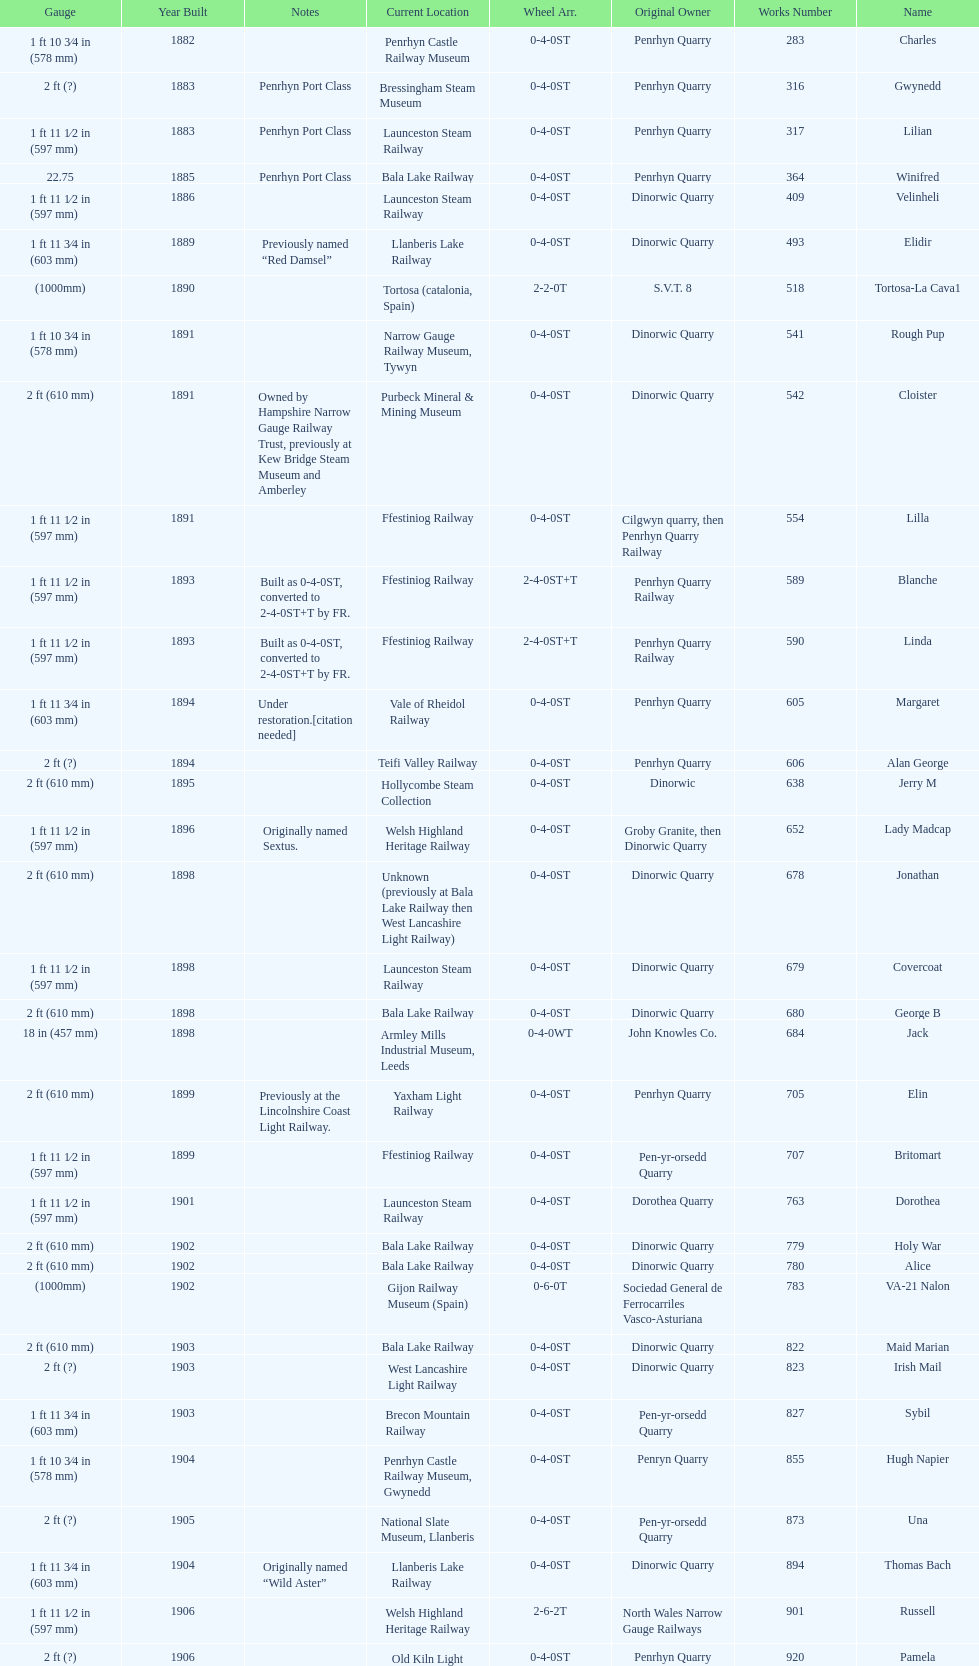How many steam locomotives are currently located at the bala lake railway? 364. Can you give me this table as a dict? {'header': ['Gauge', 'Year Built', 'Notes', 'Current Location', 'Wheel Arr.', 'Original Owner', 'Works Number', 'Name'], 'rows': [['1\xa0ft 10\xa03⁄4\xa0in (578\xa0mm)', '1882', '', 'Penrhyn Castle Railway Museum', '0-4-0ST', 'Penrhyn Quarry', '283', 'Charles'], ['2\xa0ft (?)', '1883', 'Penrhyn Port Class', 'Bressingham Steam Museum', '0-4-0ST', 'Penrhyn Quarry', '316', 'Gwynedd'], ['1\xa0ft 11\xa01⁄2\xa0in (597\xa0mm)', '1883', 'Penrhyn Port Class', 'Launceston Steam Railway', '0-4-0ST', 'Penrhyn Quarry', '317', 'Lilian'], ['22.75', '1885', 'Penrhyn Port Class', 'Bala Lake Railway', '0-4-0ST', 'Penrhyn Quarry', '364', 'Winifred'], ['1\xa0ft 11\xa01⁄2\xa0in (597\xa0mm)', '1886', '', 'Launceston Steam Railway', '0-4-0ST', 'Dinorwic Quarry', '409', 'Velinheli'], ['1\xa0ft 11\xa03⁄4\xa0in (603\xa0mm)', '1889', 'Previously named “Red Damsel”', 'Llanberis Lake Railway', '0-4-0ST', 'Dinorwic Quarry', '493', 'Elidir'], ['(1000mm)', '1890', '', 'Tortosa (catalonia, Spain)', '2-2-0T', 'S.V.T. 8', '518', 'Tortosa-La Cava1'], ['1\xa0ft 10\xa03⁄4\xa0in (578\xa0mm)', '1891', '', 'Narrow Gauge Railway Museum, Tywyn', '0-4-0ST', 'Dinorwic Quarry', '541', 'Rough Pup'], ['2\xa0ft (610\xa0mm)', '1891', 'Owned by Hampshire Narrow Gauge Railway Trust, previously at Kew Bridge Steam Museum and Amberley', 'Purbeck Mineral & Mining Museum', '0-4-0ST', 'Dinorwic Quarry', '542', 'Cloister'], ['1\xa0ft 11\xa01⁄2\xa0in (597\xa0mm)', '1891', '', 'Ffestiniog Railway', '0-4-0ST', 'Cilgwyn quarry, then Penrhyn Quarry Railway', '554', 'Lilla'], ['1\xa0ft 11\xa01⁄2\xa0in (597\xa0mm)', '1893', 'Built as 0-4-0ST, converted to 2-4-0ST+T by FR.', 'Ffestiniog Railway', '2-4-0ST+T', 'Penrhyn Quarry Railway', '589', 'Blanche'], ['1\xa0ft 11\xa01⁄2\xa0in (597\xa0mm)', '1893', 'Built as 0-4-0ST, converted to 2-4-0ST+T by FR.', 'Ffestiniog Railway', '2-4-0ST+T', 'Penrhyn Quarry Railway', '590', 'Linda'], ['1\xa0ft 11\xa03⁄4\xa0in (603\xa0mm)', '1894', 'Under restoration.[citation needed]', 'Vale of Rheidol Railway', '0-4-0ST', 'Penrhyn Quarry', '605', 'Margaret'], ['2\xa0ft (?)', '1894', '', 'Teifi Valley Railway', '0-4-0ST', 'Penrhyn Quarry', '606', 'Alan George'], ['2\xa0ft (610\xa0mm)', '1895', '', 'Hollycombe Steam Collection', '0-4-0ST', 'Dinorwic', '638', 'Jerry M'], ['1\xa0ft 11\xa01⁄2\xa0in (597\xa0mm)', '1896', 'Originally named Sextus.', 'Welsh Highland Heritage Railway', '0-4-0ST', 'Groby Granite, then Dinorwic Quarry', '652', 'Lady Madcap'], ['2\xa0ft (610\xa0mm)', '1898', '', 'Unknown (previously at Bala Lake Railway then West Lancashire Light Railway)', '0-4-0ST', 'Dinorwic Quarry', '678', 'Jonathan'], ['1\xa0ft 11\xa01⁄2\xa0in (597\xa0mm)', '1898', '', 'Launceston Steam Railway', '0-4-0ST', 'Dinorwic Quarry', '679', 'Covercoat'], ['2\xa0ft (610\xa0mm)', '1898', '', 'Bala Lake Railway', '0-4-0ST', 'Dinorwic Quarry', '680', 'George B'], ['18\xa0in (457\xa0mm)', '1898', '', 'Armley Mills Industrial Museum, Leeds', '0-4-0WT', 'John Knowles Co.', '684', 'Jack'], ['2\xa0ft (610\xa0mm)', '1899', 'Previously at the Lincolnshire Coast Light Railway.', 'Yaxham Light Railway', '0-4-0ST', 'Penrhyn Quarry', '705', 'Elin'], ['1\xa0ft 11\xa01⁄2\xa0in (597\xa0mm)', '1899', '', 'Ffestiniog Railway', '0-4-0ST', 'Pen-yr-orsedd Quarry', '707', 'Britomart'], ['1\xa0ft 11\xa01⁄2\xa0in (597\xa0mm)', '1901', '', 'Launceston Steam Railway', '0-4-0ST', 'Dorothea Quarry', '763', 'Dorothea'], ['2\xa0ft (610\xa0mm)', '1902', '', 'Bala Lake Railway', '0-4-0ST', 'Dinorwic Quarry', '779', 'Holy War'], ['2\xa0ft (610\xa0mm)', '1902', '', 'Bala Lake Railway', '0-4-0ST', 'Dinorwic Quarry', '780', 'Alice'], ['(1000mm)', '1902', '', 'Gijon Railway Museum (Spain)', '0-6-0T', 'Sociedad General de Ferrocarriles Vasco-Asturiana', '783', 'VA-21 Nalon'], ['2\xa0ft (610\xa0mm)', '1903', '', 'Bala Lake Railway', '0-4-0ST', 'Dinorwic Quarry', '822', 'Maid Marian'], ['2\xa0ft (?)', '1903', '', 'West Lancashire Light Railway', '0-4-0ST', 'Dinorwic Quarry', '823', 'Irish Mail'], ['1\xa0ft 11\xa03⁄4\xa0in (603\xa0mm)', '1903', '', 'Brecon Mountain Railway', '0-4-0ST', 'Pen-yr-orsedd Quarry', '827', 'Sybil'], ['1\xa0ft 10\xa03⁄4\xa0in (578\xa0mm)', '1904', '', 'Penrhyn Castle Railway Museum, Gwynedd', '0-4-0ST', 'Penryn Quarry', '855', 'Hugh Napier'], ['2\xa0ft (?)', '1905', '', 'National Slate Museum, Llanberis', '0-4-0ST', 'Pen-yr-orsedd Quarry', '873', 'Una'], ['1\xa0ft 11\xa03⁄4\xa0in (603\xa0mm)', '1904', 'Originally named “Wild Aster”', 'Llanberis Lake Railway', '0-4-0ST', 'Dinorwic Quarry', '894', 'Thomas Bach'], ['1\xa0ft 11\xa01⁄2\xa0in (597\xa0mm)', '1906', '', 'Welsh Highland Heritage Railway', '2-6-2T', 'North Wales Narrow Gauge Railways', '901', 'Russell'], ['2\xa0ft (?)', '1906', '', 'Old Kiln Light Railway', '0-4-0ST', 'Penrhyn Quarry', '920', 'Pamela'], ['2\xa0ft (?)', '1909', 'previously George Sholto', 'Bressingham Steam Museum', '0-4-0ST', 'Penrhyn Quarry', '994', 'Bill Harvey'], ['1\xa0ft\xa011\xa01⁄2\xa0in (597\xa0mm)', '1918', '[citation needed]', 'Pampas Safari, Gravataí, RS, Brazil', '4-6-0T', 'British War Department\\nEFOP #203', '1312', '---'], ['3\xa0ft\xa03\xa03⁄8\xa0in (1,000\xa0mm)', '1918\\nor\\n1921?', '[citation needed]', 'Usina Laginha, União dos Palmares, AL, Brazil', '0-6-2T', 'British War Department\\nUsina Leão Utinga #1\\nUsina Laginha #1', '1313', '---'], ['18\xa0in (457\xa0mm)', '1920', '', 'Richard Farmer current owner, Northridge, California, USA', '0-4-0WT', 'John Knowles Co.', '1404', 'Gwen'], ['2\xa0ft (610\xa0mm)', '1922', '', 'Bredgar and Wormshill Light Railway', '0-4-0ST', 'Dinorwic', '1429', 'Lady Joan'], ['1\xa0ft 11\xa03⁄4\xa0in (603\xa0mm)', '1922', '', 'Llanberis Lake Railway', '0-4-0ST', 'Dinorwic Quarry', '1430', 'Dolbadarn'], ['2\xa0ft (?)', '1937', '', 'South Tynedale Railway', '0-4-2T', 'Umtwalumi Valley Estate, Natal', '1859', '16 Carlisle'], ['2\xa0ft (?)', '1940', '', 'North Gloucestershire Railway', '0-4-2T', 'Chaka’s Kraal Sugar Estates, Natal', '2075', 'Chaka’s Kraal No. 6'], ['2\xa0ft 6\xa0in (762\xa0mm)', '1954', '', 'Welshpool and Llanfair Light Railway', '2-6-2T', 'Sierra Leone Government Railway', '3815', '14'], ['2\xa0ft (610\xa0mm)', '1971', 'Converted from 750\xa0mm (2\xa0ft\xa05\xa01⁄2\xa0in) gauge. Last steam locomotive to be built by Hunslet, and the last industrial steam locomotive built in Britain.', 'Statfold Barn Railway', '0-4-2ST', 'Trangkil Sugar Mill, Indonesia', '3902', 'Trangkil No.4']]} 